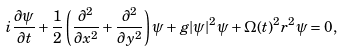Convert formula to latex. <formula><loc_0><loc_0><loc_500><loc_500>i \frac { \partial \psi } { \partial t } + \frac { 1 } { 2 } \left ( \frac { \partial ^ { 2 } } { \partial x ^ { 2 } } + \frac { \partial ^ { 2 } } { \partial y ^ { 2 } } \right ) \psi + g | \psi | ^ { 2 } \psi + \Omega ( t ) ^ { 2 } r ^ { 2 } \psi = 0 ,</formula> 